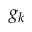Convert formula to latex. <formula><loc_0><loc_0><loc_500><loc_500>g _ { k }</formula> 